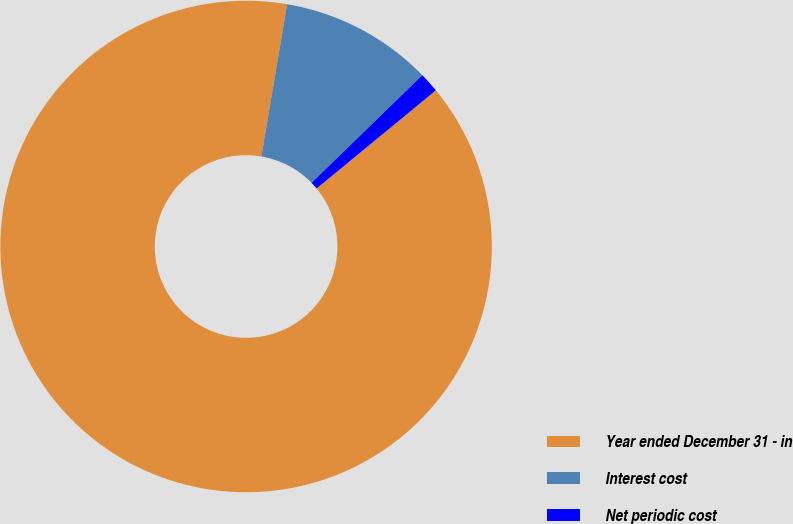Convert chart. <chart><loc_0><loc_0><loc_500><loc_500><pie_chart><fcel>Year ended December 31 - in<fcel>Interest cost<fcel>Net periodic cost<nl><fcel>88.62%<fcel>10.05%<fcel>1.32%<nl></chart> 